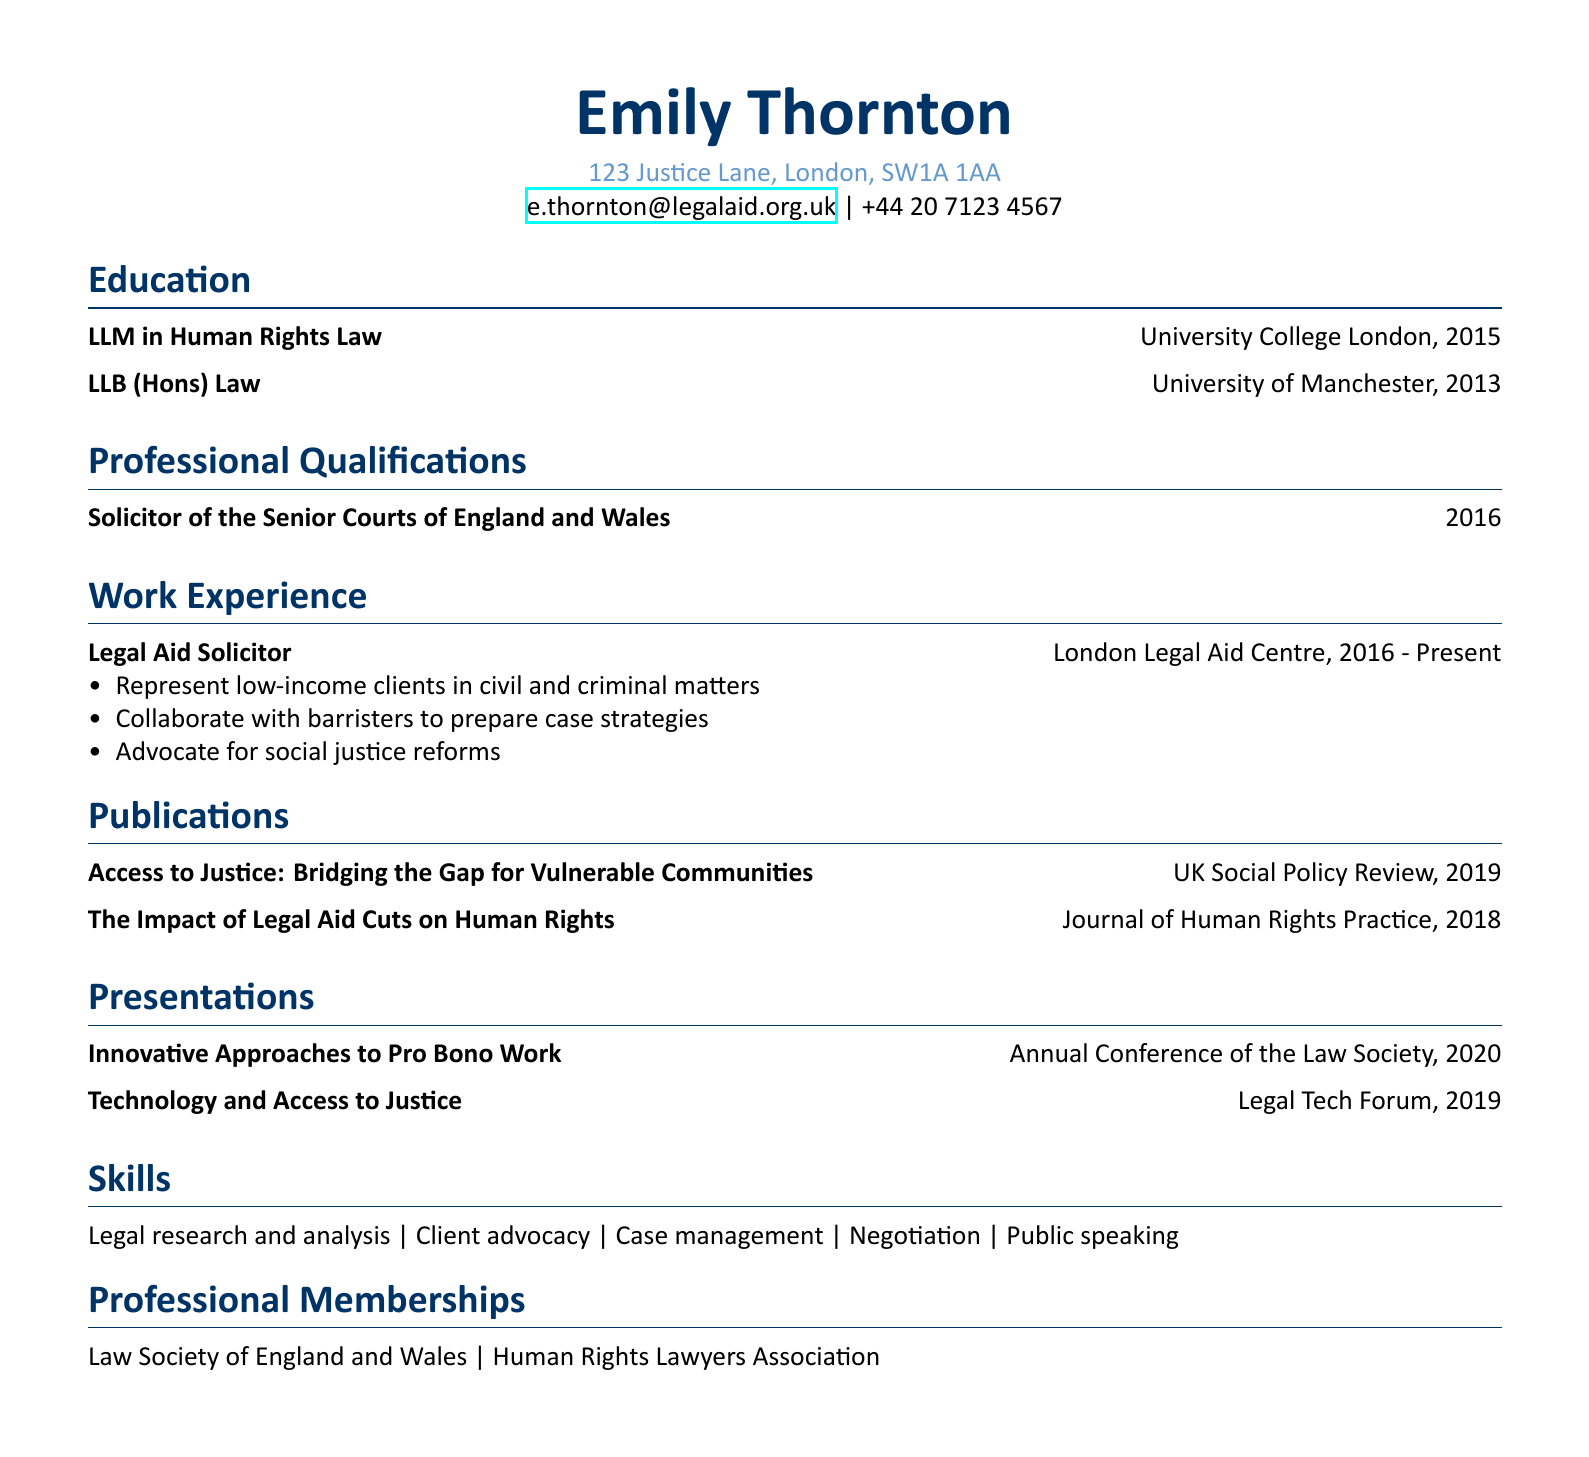What degree did Emily earn in 2015? The document states that Emily earned an LLM in Human Rights Law in 2015.
Answer: LLM in Human Rights Law Where does Emily work? The work experience section indicates that Emily works at the London Legal Aid Centre.
Answer: London Legal Aid Centre What year did Emily become a solicitor? The professional qualifications section specifies that Emily became a solicitor in 2016.
Answer: 2016 What is the title of Emily's publication in 2019? The publications section lists "Access to Justice: Bridging the Gap for Vulnerable Communities" as a publication in 2019.
Answer: Access to Justice: Bridging the Gap for Vulnerable Communities What presentation did Emily give at the Annual Conference of the Law Society? The presentation section mentions that Emily presented "Innovative Approaches to Pro Bono Work" at the Annual Conference of the Law Society.
Answer: Innovative Approaches to Pro Bono Work How many years of experience does Emily have as a Legal Aid Solicitor? Emily has been a Legal Aid Solicitor since 2016 and is currently in 2023, thus she has approximately 7 years of experience.
Answer: 7 years Which professional memberships does Emily hold? The document lists memberships in the Law Society of England and Wales and the Human Rights Lawyers Association.
Answer: Law Society of England and Wales, Human Rights Lawyers Association What skills does Emily possess related to her profession? The skills section enumerates her abilities including legal research, advocacy, and public speaking.
Answer: Legal research and analysis, Client advocacy, Case management, Negotiation, Public speaking 